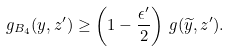Convert formula to latex. <formula><loc_0><loc_0><loc_500><loc_500>g _ { B _ { 4 } } ( y , z ^ { \prime } ) \geq \left ( 1 - \frac { \epsilon ^ { \prime } } { 2 } \right ) \, g ( \widetilde { y } , z ^ { \prime } ) .</formula> 